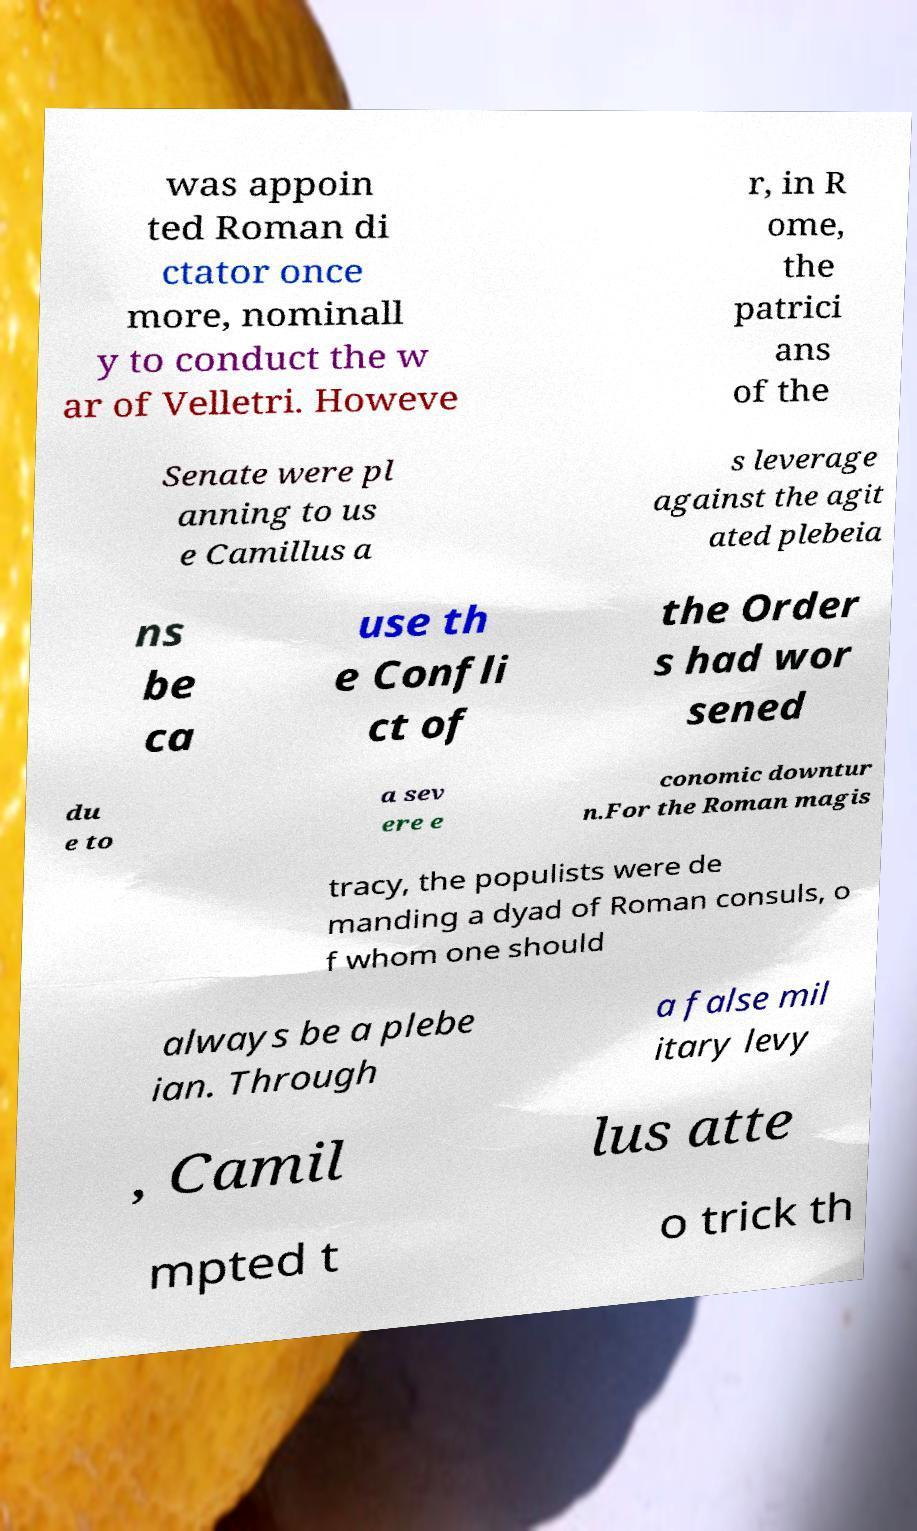Can you read and provide the text displayed in the image?This photo seems to have some interesting text. Can you extract and type it out for me? was appoin ted Roman di ctator once more, nominall y to conduct the w ar of Velletri. Howeve r, in R ome, the patrici ans of the Senate were pl anning to us e Camillus a s leverage against the agit ated plebeia ns be ca use th e Confli ct of the Order s had wor sened du e to a sev ere e conomic downtur n.For the Roman magis tracy, the populists were de manding a dyad of Roman consuls, o f whom one should always be a plebe ian. Through a false mil itary levy , Camil lus atte mpted t o trick th 